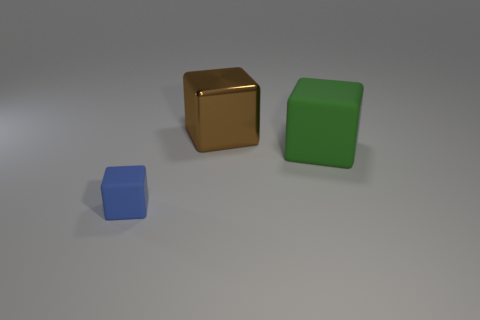Subtract all rubber blocks. How many blocks are left? 1 Add 2 large matte cubes. How many objects exist? 5 Subtract all brown blocks. How many blocks are left? 2 Add 3 brown shiny objects. How many brown shiny objects exist? 4 Subtract 1 green cubes. How many objects are left? 2 Subtract all cyan cubes. Subtract all yellow cylinders. How many cubes are left? 3 Subtract all big red metal cubes. Subtract all large green rubber blocks. How many objects are left? 2 Add 1 green matte things. How many green matte things are left? 2 